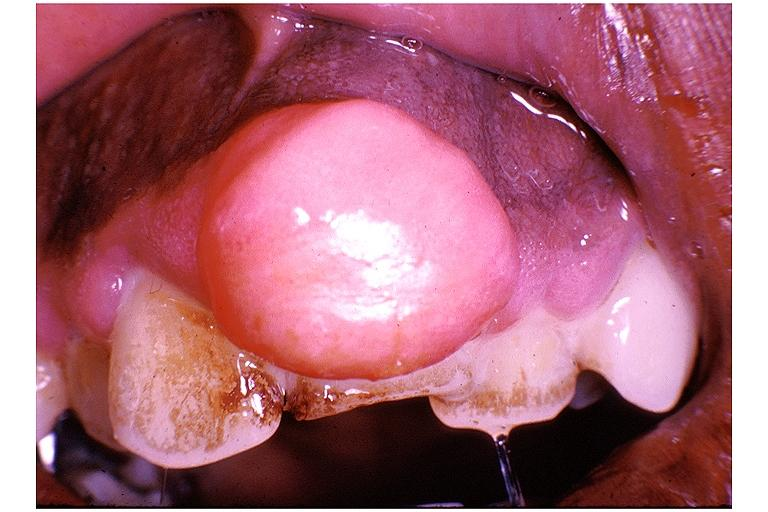what does this image show?
Answer the question using a single word or phrase. Periodontal fibroma 